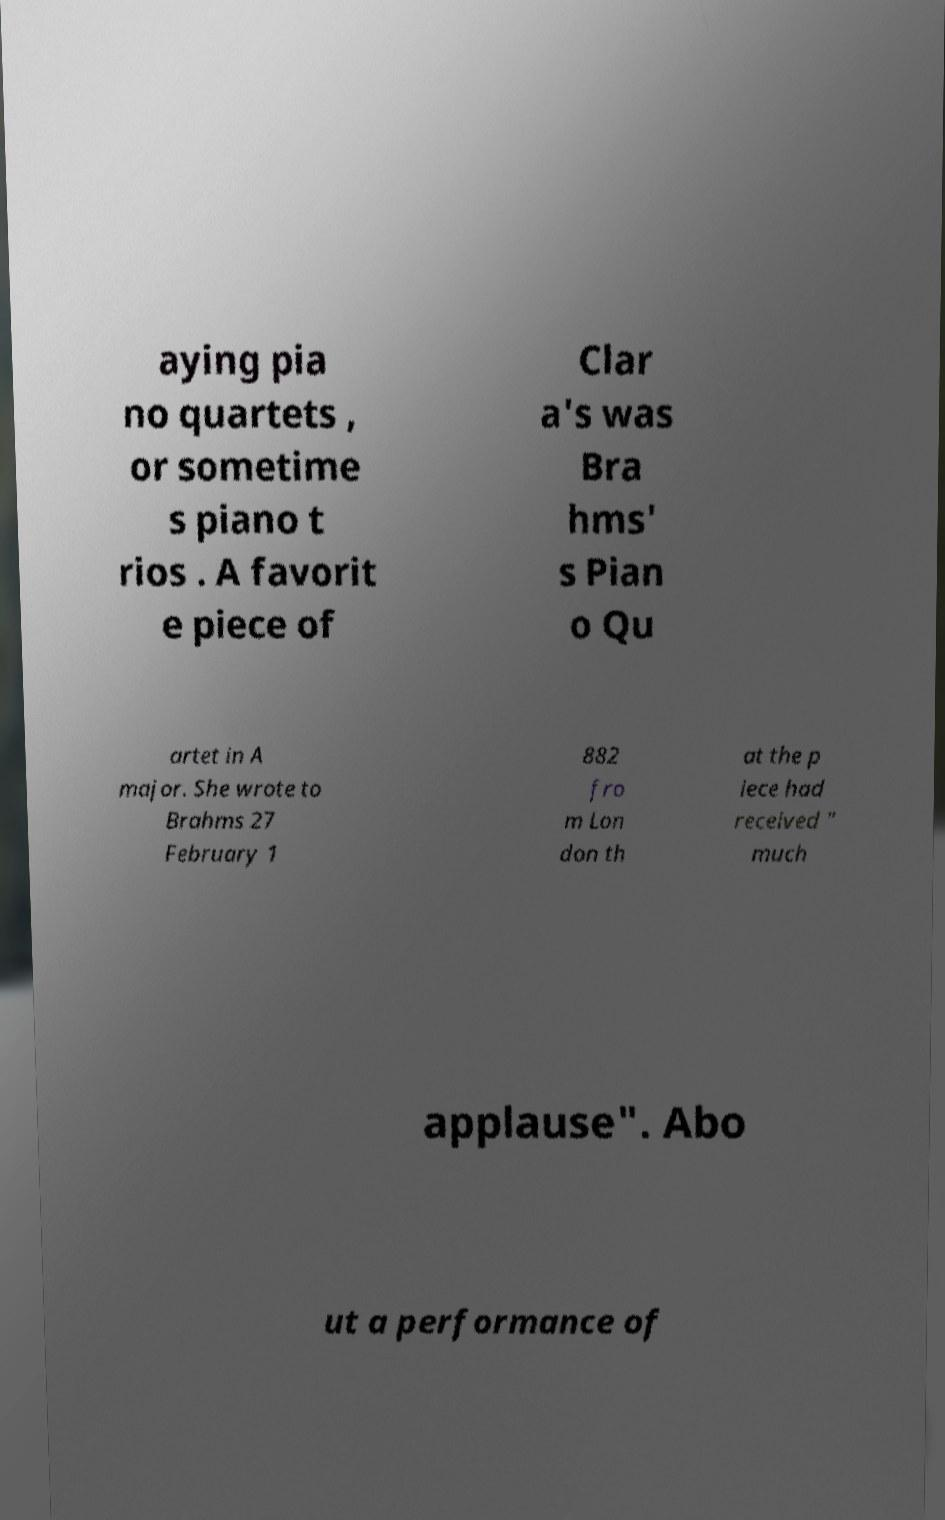Please identify and transcribe the text found in this image. aying pia no quartets , or sometime s piano t rios . A favorit e piece of Clar a's was Bra hms' s Pian o Qu artet in A major. She wrote to Brahms 27 February 1 882 fro m Lon don th at the p iece had received " much applause". Abo ut a performance of 